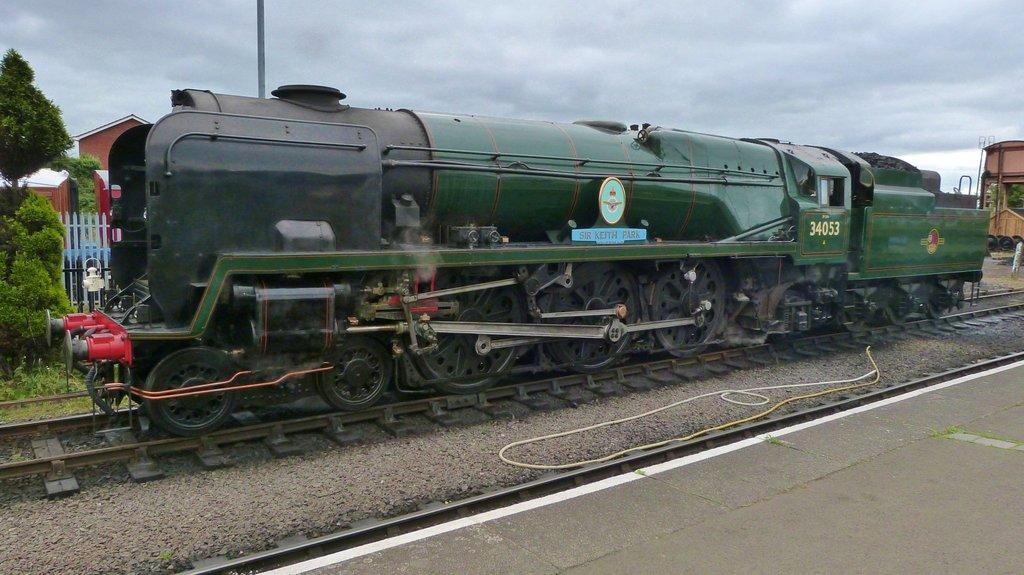What is the primary surface visible in the image? There is a ground in the image. What object is located beside the ground? There is a rope beside the ground. What mode of transportation can be seen in the image? There is a train on a railway track in the image. What type of structures can be seen in the background of the image? There are buildings and a fence in the background of the image. What type of vegetation is visible in the background of the image? There are trees in the background of the image. What other object can be seen in the background of the image? There is a pole in the background of the image. What part of the natural environment is visible in the background of the image? The sky is visible in the background of the image. What type of grain is being harvested on the ground in the image? There is no grain being harvested in the image; the ground is simply a surface on which other objects are placed. 